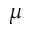<formula> <loc_0><loc_0><loc_500><loc_500>\mu</formula> 